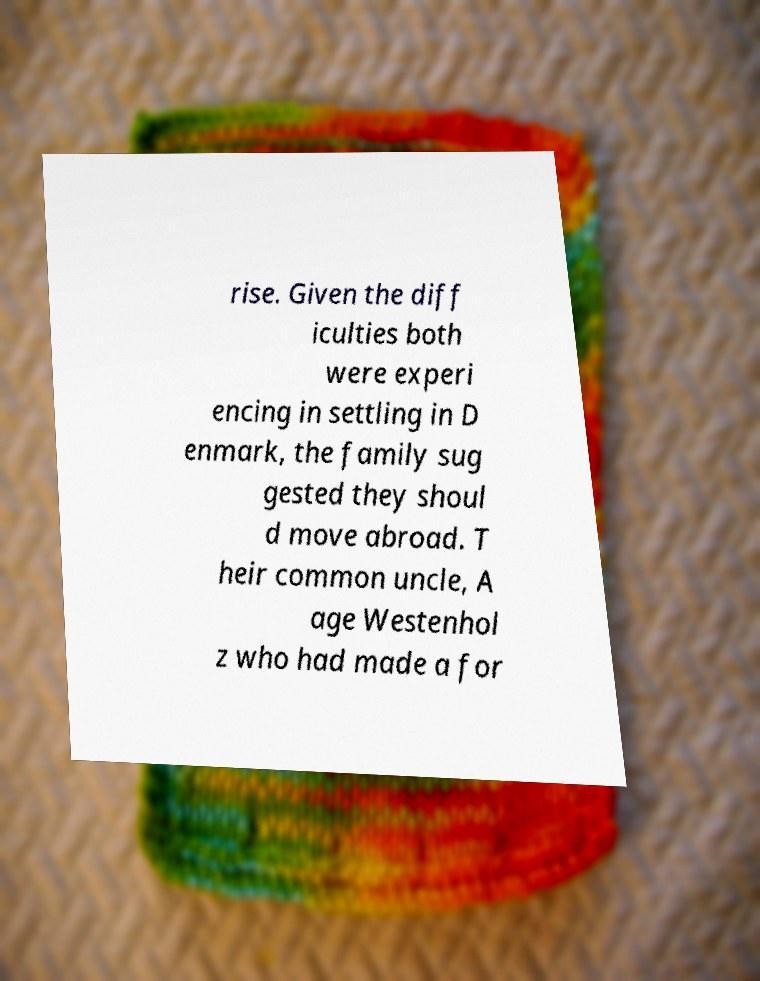Could you extract and type out the text from this image? rise. Given the diff iculties both were experi encing in settling in D enmark, the family sug gested they shoul d move abroad. T heir common uncle, A age Westenhol z who had made a for 